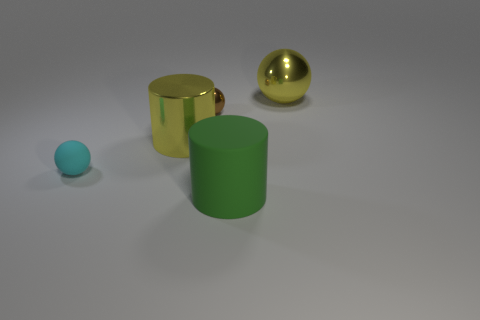What is the size of the object that is both on the right side of the yellow shiny cylinder and in front of the tiny brown metal object?
Provide a succinct answer. Large. There is another cylinder that is the same size as the green cylinder; what is it made of?
Give a very brief answer. Metal. Are there any yellow shiny things of the same size as the rubber cylinder?
Your answer should be very brief. Yes. There is a cylinder on the left side of the large green matte thing; does it have the same color as the metal ball in front of the large sphere?
Offer a very short reply. No. How many metal objects are tiny cyan cubes or small things?
Make the answer very short. 1. There is a large thing that is behind the small sphere that is to the right of the small cyan sphere; what number of rubber cylinders are to the right of it?
Keep it short and to the point. 0. There is a green object that is made of the same material as the cyan ball; what size is it?
Offer a very short reply. Large. How many tiny rubber spheres are the same color as the metal cylinder?
Provide a succinct answer. 0. There is a yellow shiny thing on the left side of the green rubber object; is it the same size as the tiny cyan ball?
Your answer should be very brief. No. The big thing that is both behind the green cylinder and to the right of the small brown metallic sphere is what color?
Give a very brief answer. Yellow. 